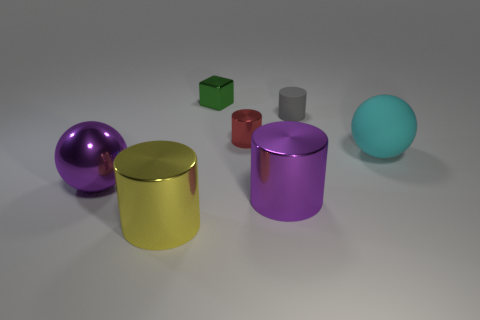Subtract 1 cylinders. How many cylinders are left? 3 Add 2 large cyan spheres. How many objects exist? 9 Subtract all brown cylinders. Subtract all red blocks. How many cylinders are left? 4 Subtract all spheres. How many objects are left? 5 Add 5 blue rubber things. How many blue rubber things exist? 5 Subtract 1 yellow cylinders. How many objects are left? 6 Subtract all small blue blocks. Subtract all red metallic cylinders. How many objects are left? 6 Add 2 red metallic cylinders. How many red metallic cylinders are left? 3 